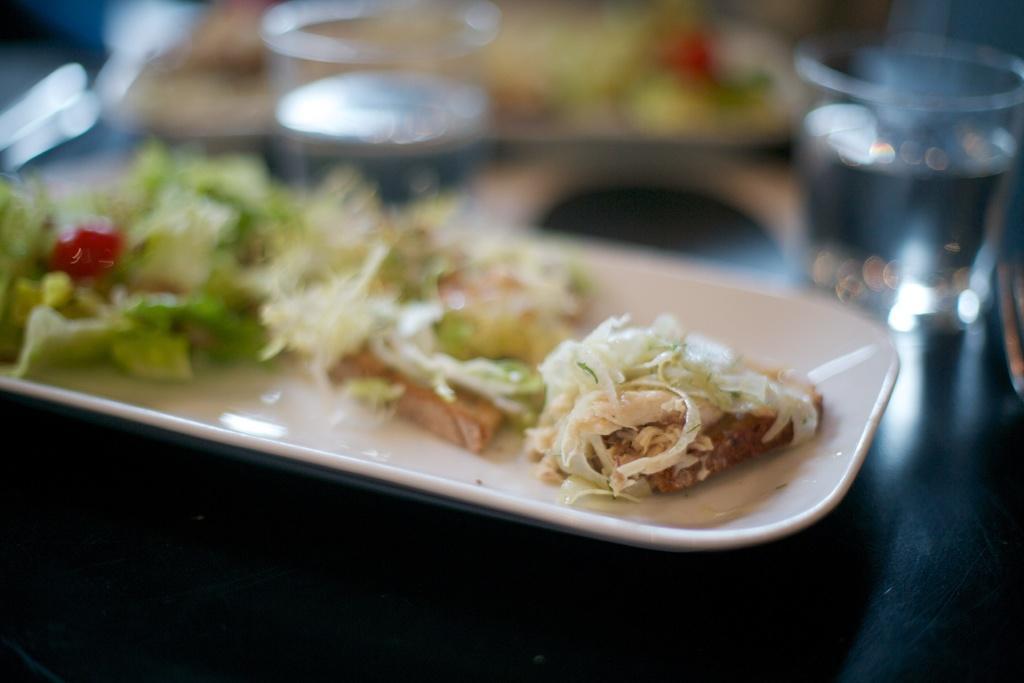Can you describe this image briefly? In the image in the center there is a table. On the table, we can see plates, glasses and some food items. 